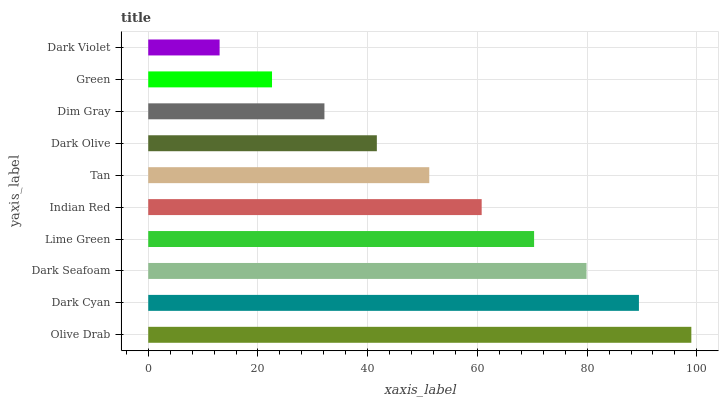Is Dark Violet the minimum?
Answer yes or no. Yes. Is Olive Drab the maximum?
Answer yes or no. Yes. Is Dark Cyan the minimum?
Answer yes or no. No. Is Dark Cyan the maximum?
Answer yes or no. No. Is Olive Drab greater than Dark Cyan?
Answer yes or no. Yes. Is Dark Cyan less than Olive Drab?
Answer yes or no. Yes. Is Dark Cyan greater than Olive Drab?
Answer yes or no. No. Is Olive Drab less than Dark Cyan?
Answer yes or no. No. Is Indian Red the high median?
Answer yes or no. Yes. Is Tan the low median?
Answer yes or no. Yes. Is Lime Green the high median?
Answer yes or no. No. Is Dim Gray the low median?
Answer yes or no. No. 